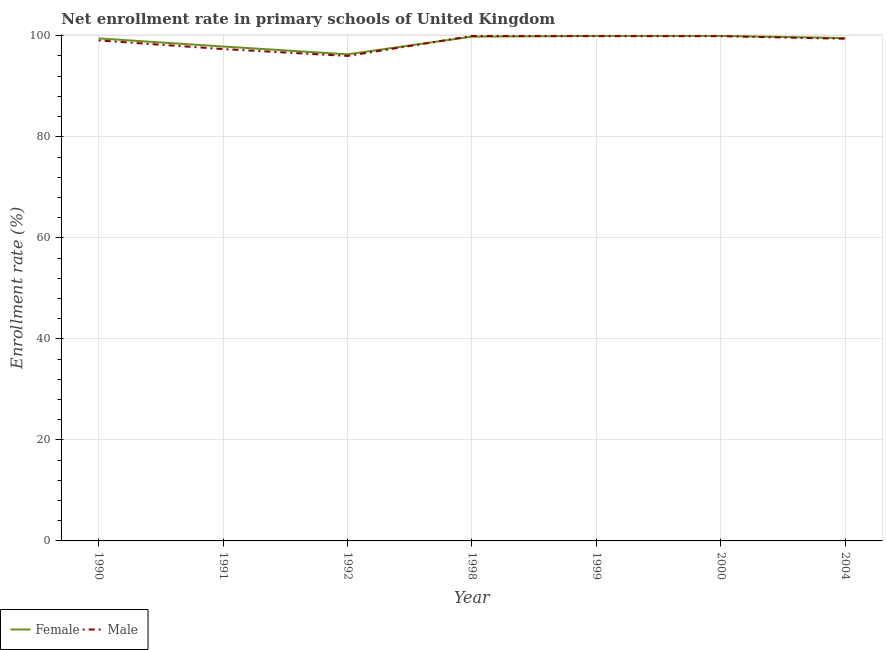Is the number of lines equal to the number of legend labels?
Offer a very short reply. Yes. What is the enrollment rate of male students in 1999?
Make the answer very short. 99.92. Across all years, what is the maximum enrollment rate of female students?
Offer a very short reply. 99.98. Across all years, what is the minimum enrollment rate of female students?
Your answer should be compact. 96.34. What is the total enrollment rate of female students in the graph?
Offer a very short reply. 693.03. What is the difference between the enrollment rate of male students in 1990 and that in 2000?
Your answer should be very brief. -0.84. What is the difference between the enrollment rate of male students in 1991 and the enrollment rate of female students in 2000?
Your response must be concise. -2.61. What is the average enrollment rate of female students per year?
Offer a terse response. 99. In the year 2004, what is the difference between the enrollment rate of male students and enrollment rate of female students?
Provide a short and direct response. -0.13. In how many years, is the enrollment rate of male students greater than 36 %?
Provide a short and direct response. 7. What is the ratio of the enrollment rate of male students in 1992 to that in 2000?
Your answer should be very brief. 0.96. Is the enrollment rate of female students in 1990 less than that in 2004?
Provide a succinct answer. Yes. Is the difference between the enrollment rate of female students in 1991 and 2000 greater than the difference between the enrollment rate of male students in 1991 and 2000?
Your answer should be compact. Yes. What is the difference between the highest and the second highest enrollment rate of male students?
Make the answer very short. 0.04. What is the difference between the highest and the lowest enrollment rate of female students?
Offer a very short reply. 3.65. In how many years, is the enrollment rate of female students greater than the average enrollment rate of female students taken over all years?
Make the answer very short. 5. Does the enrollment rate of female students monotonically increase over the years?
Make the answer very short. No. Is the enrollment rate of female students strictly greater than the enrollment rate of male students over the years?
Your answer should be compact. No. How many lines are there?
Offer a terse response. 2. Does the graph contain any zero values?
Provide a succinct answer. No. Does the graph contain grids?
Keep it short and to the point. Yes. How many legend labels are there?
Keep it short and to the point. 2. What is the title of the graph?
Your answer should be very brief. Net enrollment rate in primary schools of United Kingdom. Does "DAC donors" appear as one of the legend labels in the graph?
Your answer should be compact. No. What is the label or title of the Y-axis?
Keep it short and to the point. Enrollment rate (%). What is the Enrollment rate (%) of Female in 1990?
Ensure brevity in your answer.  99.48. What is the Enrollment rate (%) of Male in 1990?
Offer a terse response. 99.08. What is the Enrollment rate (%) in Female in 1991?
Offer a terse response. 97.87. What is the Enrollment rate (%) in Male in 1991?
Provide a succinct answer. 97.37. What is the Enrollment rate (%) of Female in 1992?
Offer a very short reply. 96.34. What is the Enrollment rate (%) in Male in 1992?
Ensure brevity in your answer.  96.01. What is the Enrollment rate (%) of Female in 1998?
Offer a terse response. 99.83. What is the Enrollment rate (%) of Male in 1998?
Provide a succinct answer. 99.96. What is the Enrollment rate (%) of Female in 1999?
Your response must be concise. 99.98. What is the Enrollment rate (%) of Male in 1999?
Provide a short and direct response. 99.92. What is the Enrollment rate (%) of Female in 2000?
Provide a short and direct response. 99.98. What is the Enrollment rate (%) of Male in 2000?
Your response must be concise. 99.92. What is the Enrollment rate (%) in Female in 2004?
Make the answer very short. 99.54. What is the Enrollment rate (%) in Male in 2004?
Ensure brevity in your answer.  99.41. Across all years, what is the maximum Enrollment rate (%) of Female?
Offer a very short reply. 99.98. Across all years, what is the maximum Enrollment rate (%) in Male?
Provide a short and direct response. 99.96. Across all years, what is the minimum Enrollment rate (%) in Female?
Your answer should be compact. 96.34. Across all years, what is the minimum Enrollment rate (%) of Male?
Make the answer very short. 96.01. What is the total Enrollment rate (%) of Female in the graph?
Ensure brevity in your answer.  693.03. What is the total Enrollment rate (%) of Male in the graph?
Offer a terse response. 691.68. What is the difference between the Enrollment rate (%) in Female in 1990 and that in 1991?
Provide a short and direct response. 1.61. What is the difference between the Enrollment rate (%) of Male in 1990 and that in 1991?
Ensure brevity in your answer.  1.71. What is the difference between the Enrollment rate (%) in Female in 1990 and that in 1992?
Provide a succinct answer. 3.15. What is the difference between the Enrollment rate (%) in Male in 1990 and that in 1992?
Make the answer very short. 3.08. What is the difference between the Enrollment rate (%) in Female in 1990 and that in 1998?
Your answer should be compact. -0.35. What is the difference between the Enrollment rate (%) of Male in 1990 and that in 1998?
Keep it short and to the point. -0.88. What is the difference between the Enrollment rate (%) in Female in 1990 and that in 1999?
Provide a succinct answer. -0.49. What is the difference between the Enrollment rate (%) of Male in 1990 and that in 1999?
Ensure brevity in your answer.  -0.84. What is the difference between the Enrollment rate (%) in Female in 1990 and that in 2000?
Give a very brief answer. -0.5. What is the difference between the Enrollment rate (%) in Male in 1990 and that in 2000?
Provide a short and direct response. -0.84. What is the difference between the Enrollment rate (%) of Female in 1990 and that in 2004?
Ensure brevity in your answer.  -0.06. What is the difference between the Enrollment rate (%) of Male in 1990 and that in 2004?
Give a very brief answer. -0.33. What is the difference between the Enrollment rate (%) of Female in 1991 and that in 1992?
Your answer should be compact. 1.53. What is the difference between the Enrollment rate (%) in Male in 1991 and that in 1992?
Ensure brevity in your answer.  1.36. What is the difference between the Enrollment rate (%) in Female in 1991 and that in 1998?
Your response must be concise. -1.96. What is the difference between the Enrollment rate (%) of Male in 1991 and that in 1998?
Offer a very short reply. -2.59. What is the difference between the Enrollment rate (%) of Female in 1991 and that in 1999?
Make the answer very short. -2.11. What is the difference between the Enrollment rate (%) in Male in 1991 and that in 1999?
Offer a very short reply. -2.55. What is the difference between the Enrollment rate (%) of Female in 1991 and that in 2000?
Provide a short and direct response. -2.11. What is the difference between the Enrollment rate (%) in Male in 1991 and that in 2000?
Your answer should be very brief. -2.55. What is the difference between the Enrollment rate (%) in Female in 1991 and that in 2004?
Your answer should be compact. -1.67. What is the difference between the Enrollment rate (%) of Male in 1991 and that in 2004?
Keep it short and to the point. -2.04. What is the difference between the Enrollment rate (%) in Female in 1992 and that in 1998?
Give a very brief answer. -3.5. What is the difference between the Enrollment rate (%) of Male in 1992 and that in 1998?
Your response must be concise. -3.95. What is the difference between the Enrollment rate (%) of Female in 1992 and that in 1999?
Your answer should be very brief. -3.64. What is the difference between the Enrollment rate (%) in Male in 1992 and that in 1999?
Offer a very short reply. -3.91. What is the difference between the Enrollment rate (%) in Female in 1992 and that in 2000?
Keep it short and to the point. -3.65. What is the difference between the Enrollment rate (%) of Male in 1992 and that in 2000?
Your answer should be very brief. -3.91. What is the difference between the Enrollment rate (%) in Female in 1992 and that in 2004?
Provide a short and direct response. -3.21. What is the difference between the Enrollment rate (%) in Male in 1992 and that in 2004?
Offer a terse response. -3.41. What is the difference between the Enrollment rate (%) in Female in 1998 and that in 1999?
Offer a very short reply. -0.14. What is the difference between the Enrollment rate (%) of Male in 1998 and that in 1999?
Provide a succinct answer. 0.04. What is the difference between the Enrollment rate (%) of Female in 1998 and that in 2000?
Your answer should be compact. -0.15. What is the difference between the Enrollment rate (%) in Male in 1998 and that in 2000?
Ensure brevity in your answer.  0.04. What is the difference between the Enrollment rate (%) in Female in 1998 and that in 2004?
Provide a succinct answer. 0.29. What is the difference between the Enrollment rate (%) in Male in 1998 and that in 2004?
Your answer should be compact. 0.55. What is the difference between the Enrollment rate (%) in Female in 1999 and that in 2000?
Offer a terse response. -0.01. What is the difference between the Enrollment rate (%) in Male in 1999 and that in 2000?
Your response must be concise. -0. What is the difference between the Enrollment rate (%) of Female in 1999 and that in 2004?
Your response must be concise. 0.43. What is the difference between the Enrollment rate (%) in Male in 1999 and that in 2004?
Your answer should be very brief. 0.51. What is the difference between the Enrollment rate (%) in Female in 2000 and that in 2004?
Ensure brevity in your answer.  0.44. What is the difference between the Enrollment rate (%) of Male in 2000 and that in 2004?
Ensure brevity in your answer.  0.51. What is the difference between the Enrollment rate (%) of Female in 1990 and the Enrollment rate (%) of Male in 1991?
Make the answer very short. 2.11. What is the difference between the Enrollment rate (%) in Female in 1990 and the Enrollment rate (%) in Male in 1992?
Provide a succinct answer. 3.48. What is the difference between the Enrollment rate (%) in Female in 1990 and the Enrollment rate (%) in Male in 1998?
Your answer should be very brief. -0.48. What is the difference between the Enrollment rate (%) of Female in 1990 and the Enrollment rate (%) of Male in 1999?
Keep it short and to the point. -0.44. What is the difference between the Enrollment rate (%) in Female in 1990 and the Enrollment rate (%) in Male in 2000?
Give a very brief answer. -0.44. What is the difference between the Enrollment rate (%) of Female in 1990 and the Enrollment rate (%) of Male in 2004?
Make the answer very short. 0.07. What is the difference between the Enrollment rate (%) in Female in 1991 and the Enrollment rate (%) in Male in 1992?
Provide a succinct answer. 1.86. What is the difference between the Enrollment rate (%) of Female in 1991 and the Enrollment rate (%) of Male in 1998?
Keep it short and to the point. -2.09. What is the difference between the Enrollment rate (%) in Female in 1991 and the Enrollment rate (%) in Male in 1999?
Your answer should be very brief. -2.05. What is the difference between the Enrollment rate (%) of Female in 1991 and the Enrollment rate (%) of Male in 2000?
Your answer should be very brief. -2.05. What is the difference between the Enrollment rate (%) in Female in 1991 and the Enrollment rate (%) in Male in 2004?
Your answer should be compact. -1.54. What is the difference between the Enrollment rate (%) of Female in 1992 and the Enrollment rate (%) of Male in 1998?
Provide a short and direct response. -3.62. What is the difference between the Enrollment rate (%) of Female in 1992 and the Enrollment rate (%) of Male in 1999?
Offer a very short reply. -3.58. What is the difference between the Enrollment rate (%) in Female in 1992 and the Enrollment rate (%) in Male in 2000?
Offer a very short reply. -3.58. What is the difference between the Enrollment rate (%) of Female in 1992 and the Enrollment rate (%) of Male in 2004?
Provide a short and direct response. -3.08. What is the difference between the Enrollment rate (%) of Female in 1998 and the Enrollment rate (%) of Male in 1999?
Give a very brief answer. -0.09. What is the difference between the Enrollment rate (%) of Female in 1998 and the Enrollment rate (%) of Male in 2000?
Provide a succinct answer. -0.09. What is the difference between the Enrollment rate (%) of Female in 1998 and the Enrollment rate (%) of Male in 2004?
Your answer should be compact. 0.42. What is the difference between the Enrollment rate (%) of Female in 1999 and the Enrollment rate (%) of Male in 2000?
Offer a terse response. 0.06. What is the difference between the Enrollment rate (%) of Female in 1999 and the Enrollment rate (%) of Male in 2004?
Offer a terse response. 0.56. What is the difference between the Enrollment rate (%) of Female in 2000 and the Enrollment rate (%) of Male in 2004?
Offer a very short reply. 0.57. What is the average Enrollment rate (%) of Female per year?
Keep it short and to the point. 99. What is the average Enrollment rate (%) of Male per year?
Your response must be concise. 98.81. In the year 1990, what is the difference between the Enrollment rate (%) of Female and Enrollment rate (%) of Male?
Make the answer very short. 0.4. In the year 1991, what is the difference between the Enrollment rate (%) of Female and Enrollment rate (%) of Male?
Ensure brevity in your answer.  0.5. In the year 1992, what is the difference between the Enrollment rate (%) in Female and Enrollment rate (%) in Male?
Make the answer very short. 0.33. In the year 1998, what is the difference between the Enrollment rate (%) in Female and Enrollment rate (%) in Male?
Provide a short and direct response. -0.13. In the year 1999, what is the difference between the Enrollment rate (%) of Female and Enrollment rate (%) of Male?
Give a very brief answer. 0.06. In the year 2000, what is the difference between the Enrollment rate (%) of Female and Enrollment rate (%) of Male?
Your response must be concise. 0.06. In the year 2004, what is the difference between the Enrollment rate (%) in Female and Enrollment rate (%) in Male?
Your response must be concise. 0.13. What is the ratio of the Enrollment rate (%) of Female in 1990 to that in 1991?
Offer a very short reply. 1.02. What is the ratio of the Enrollment rate (%) of Male in 1990 to that in 1991?
Make the answer very short. 1.02. What is the ratio of the Enrollment rate (%) in Female in 1990 to that in 1992?
Your answer should be compact. 1.03. What is the ratio of the Enrollment rate (%) in Male in 1990 to that in 1992?
Make the answer very short. 1.03. What is the ratio of the Enrollment rate (%) of Male in 1990 to that in 1998?
Make the answer very short. 0.99. What is the ratio of the Enrollment rate (%) in Female in 1990 to that in 1999?
Provide a short and direct response. 1. What is the ratio of the Enrollment rate (%) of Female in 1990 to that in 2000?
Your answer should be very brief. 0.99. What is the ratio of the Enrollment rate (%) in Female in 1990 to that in 2004?
Provide a succinct answer. 1. What is the ratio of the Enrollment rate (%) in Male in 1990 to that in 2004?
Your response must be concise. 1. What is the ratio of the Enrollment rate (%) in Female in 1991 to that in 1992?
Provide a succinct answer. 1.02. What is the ratio of the Enrollment rate (%) in Male in 1991 to that in 1992?
Your answer should be compact. 1.01. What is the ratio of the Enrollment rate (%) of Female in 1991 to that in 1998?
Make the answer very short. 0.98. What is the ratio of the Enrollment rate (%) of Male in 1991 to that in 1998?
Give a very brief answer. 0.97. What is the ratio of the Enrollment rate (%) of Female in 1991 to that in 1999?
Provide a short and direct response. 0.98. What is the ratio of the Enrollment rate (%) in Male in 1991 to that in 1999?
Keep it short and to the point. 0.97. What is the ratio of the Enrollment rate (%) in Female in 1991 to that in 2000?
Offer a very short reply. 0.98. What is the ratio of the Enrollment rate (%) in Male in 1991 to that in 2000?
Give a very brief answer. 0.97. What is the ratio of the Enrollment rate (%) of Female in 1991 to that in 2004?
Offer a very short reply. 0.98. What is the ratio of the Enrollment rate (%) of Male in 1991 to that in 2004?
Provide a short and direct response. 0.98. What is the ratio of the Enrollment rate (%) in Female in 1992 to that in 1998?
Make the answer very short. 0.96. What is the ratio of the Enrollment rate (%) in Male in 1992 to that in 1998?
Offer a terse response. 0.96. What is the ratio of the Enrollment rate (%) in Female in 1992 to that in 1999?
Provide a succinct answer. 0.96. What is the ratio of the Enrollment rate (%) in Male in 1992 to that in 1999?
Keep it short and to the point. 0.96. What is the ratio of the Enrollment rate (%) of Female in 1992 to that in 2000?
Provide a succinct answer. 0.96. What is the ratio of the Enrollment rate (%) in Male in 1992 to that in 2000?
Offer a terse response. 0.96. What is the ratio of the Enrollment rate (%) in Female in 1992 to that in 2004?
Your answer should be very brief. 0.97. What is the ratio of the Enrollment rate (%) of Male in 1992 to that in 2004?
Offer a very short reply. 0.97. What is the ratio of the Enrollment rate (%) of Female in 1998 to that in 1999?
Your response must be concise. 1. What is the ratio of the Enrollment rate (%) of Male in 1998 to that in 2000?
Your answer should be compact. 1. What is the ratio of the Enrollment rate (%) in Female in 1998 to that in 2004?
Give a very brief answer. 1. What is the ratio of the Enrollment rate (%) in Male in 1998 to that in 2004?
Give a very brief answer. 1.01. What is the ratio of the Enrollment rate (%) of Female in 1999 to that in 2004?
Your answer should be very brief. 1. What is the ratio of the Enrollment rate (%) of Female in 2000 to that in 2004?
Your answer should be compact. 1. What is the difference between the highest and the second highest Enrollment rate (%) in Female?
Offer a very short reply. 0.01. What is the difference between the highest and the second highest Enrollment rate (%) of Male?
Keep it short and to the point. 0.04. What is the difference between the highest and the lowest Enrollment rate (%) of Female?
Your response must be concise. 3.65. What is the difference between the highest and the lowest Enrollment rate (%) in Male?
Keep it short and to the point. 3.95. 